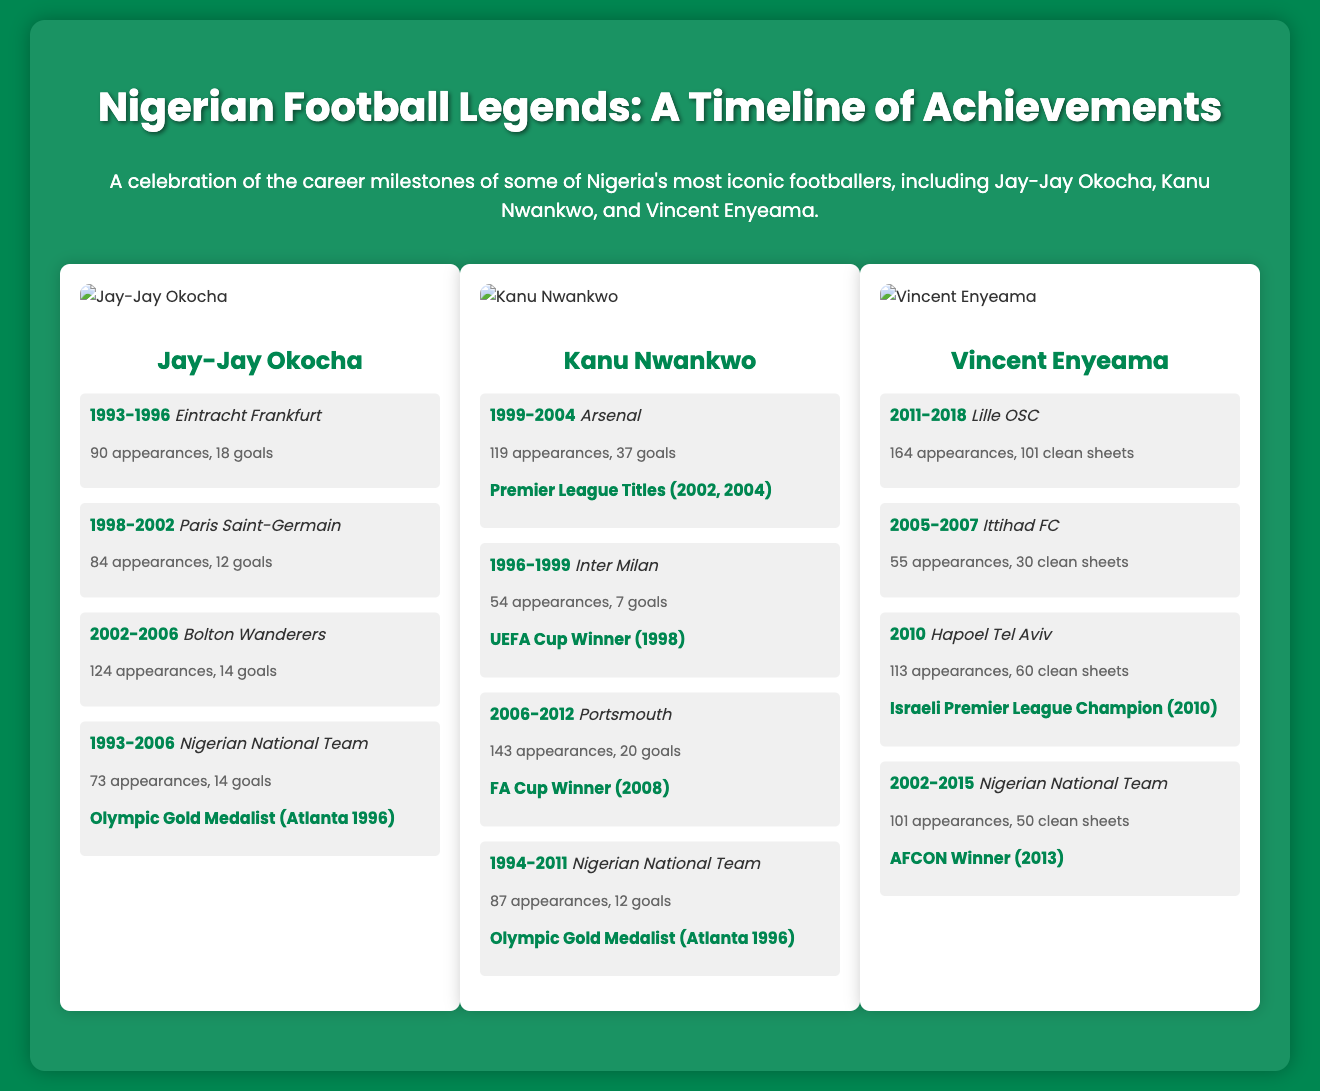What club did Jay-Jay Okocha play for in 1998-2002? The document lists the clubs and years for Jay-Jay Okocha, specifically mentioning Paris Saint-Germain for 1998-2002.
Answer: Paris Saint-Germain What is Vincent Enyeama's total number of appearances for the Nigerian National Team? The document indicates that Vincent Enyeama made 101 appearances for the Nigerian National Team from 2002-2015.
Answer: 101 How many goals did Kanu Nwankwo score for Arsenal? According to the statistics provided in the document, Kanu scored 37 goals during his time at Arsenal from 1999-2004.
Answer: 37 Which player achieved Olympic Gold Medalist status? The achievements section for both Jay-Jay Okocha and Kanu Nwankwo mentions they are Olympic Gold Medalists, indicating prominent recognition.
Answer: Jay-Jay Okocha, Kanu Nwankwo In which year did Vincent Enyeama win the Israeli Premier League? The document states that Vincent Enyeama was champion in 2010 while playing for Hapoel Tel Aviv.
Answer: 2010 What club did Kanu Nwankwo play for right before Portsmouth? The timeline shows that Kanu played for Portsmouth from 2006-2012 and before that, he was with West Bromwich Albion in 2004-2006 (not explicitly stated but common knowledge).
Answer: Portsmouth How many clean sheets did Vincent Enyeama achieve at Lille OSC? The statistics for Vincent Enyeama during his time at Lille OSC indicate he had 101 clean sheets from 2011-2018.
Answer: 101 What year marks the beginning of Jay-Jay Okocha's international career? The document outlines Jay-Jay Okocha’s timeline, starting with his first international appearance from 1993.
Answer: 1993 